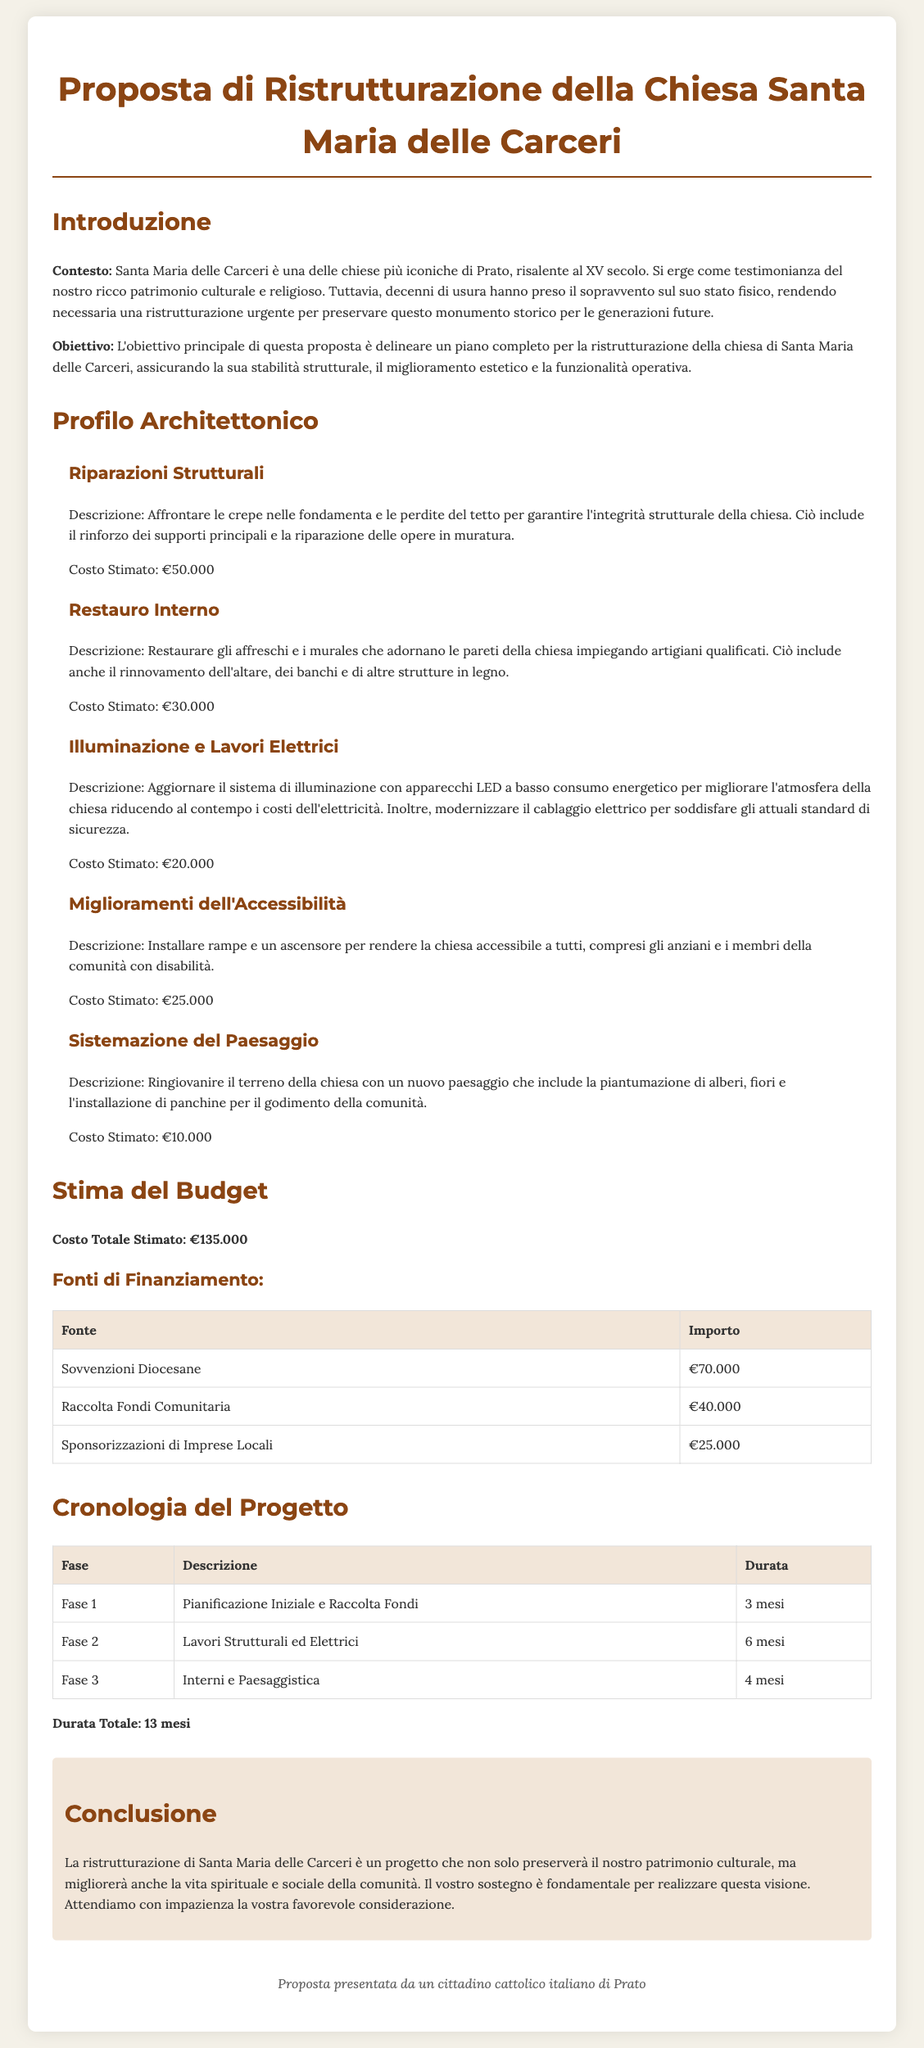what is the name of the church proposed for renovation? The document identifies the church as "Santa Maria delle Carceri."
Answer: Santa Maria delle Carceri what is the estimated total cost for the renovation? The total cost is mentioned in the budget estimation section.
Answer: €135.000 how much is allocated for structural repairs? The document specifies the cost for structural repairs in the architectural profile section.
Answer: €50.000 how many phases are outlined in the project timeline? The timeline section of the document details the phases involved in the project.
Answer: 3 what is the duration of the planning phase? The planning phase duration is found in the project timeline table.
Answer: 3 mesi who are the sources of funding mentioned for the project? The budget estimation section lists specific sources of financing for the renovation.
Answer: Sovvenzioni Diocesane, Raccolta Fondi Comunitaria, Sponsorizzazioni di Imprese Locali what is the purpose of the renovation project? The introduction section describes the objectives of the renovation project.
Answer: Preservare il patrimonio culturale what is the duration of the total project? The document provides the total duration in the project timeline section.
Answer: 13 mesi what improvements are proposed for accessibility? The architectural profile section outlines the planned improvements for accessibility.
Answer: Installare rampe e un ascensore 